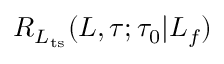Convert formula to latex. <formula><loc_0><loc_0><loc_500><loc_500>R _ { L _ { t s } } ( L , \tau ; \tau _ { 0 } | L _ { f } )</formula> 